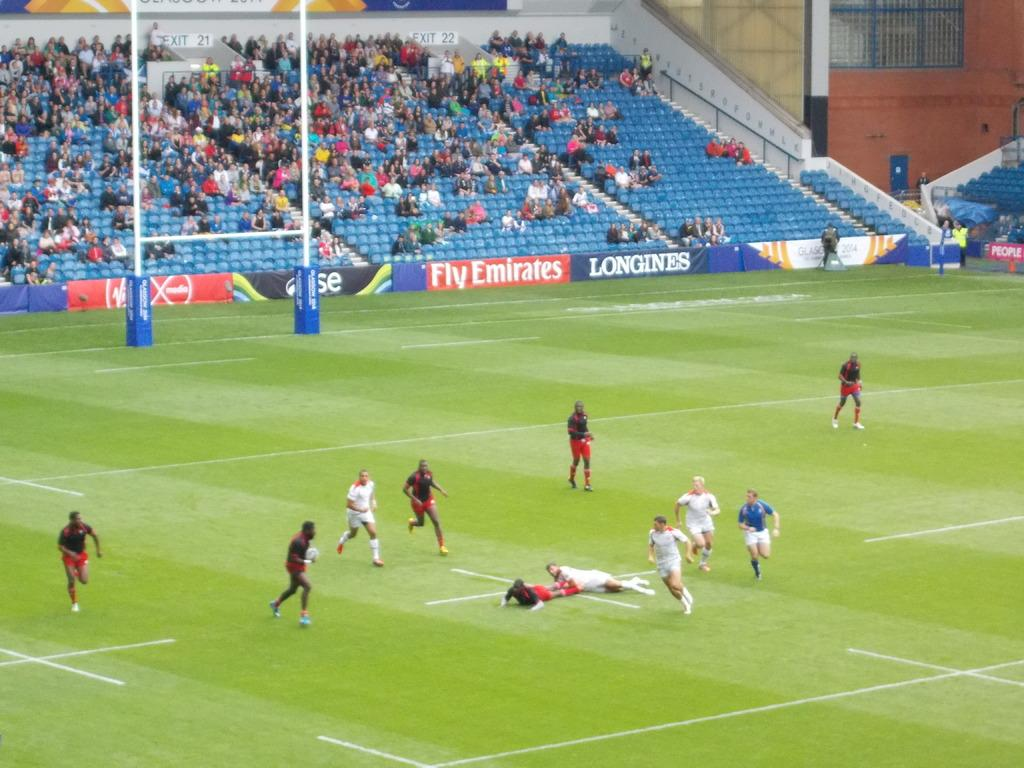<image>
Relay a brief, clear account of the picture shown. A soccer field with an advertisement for Fly Emirates 